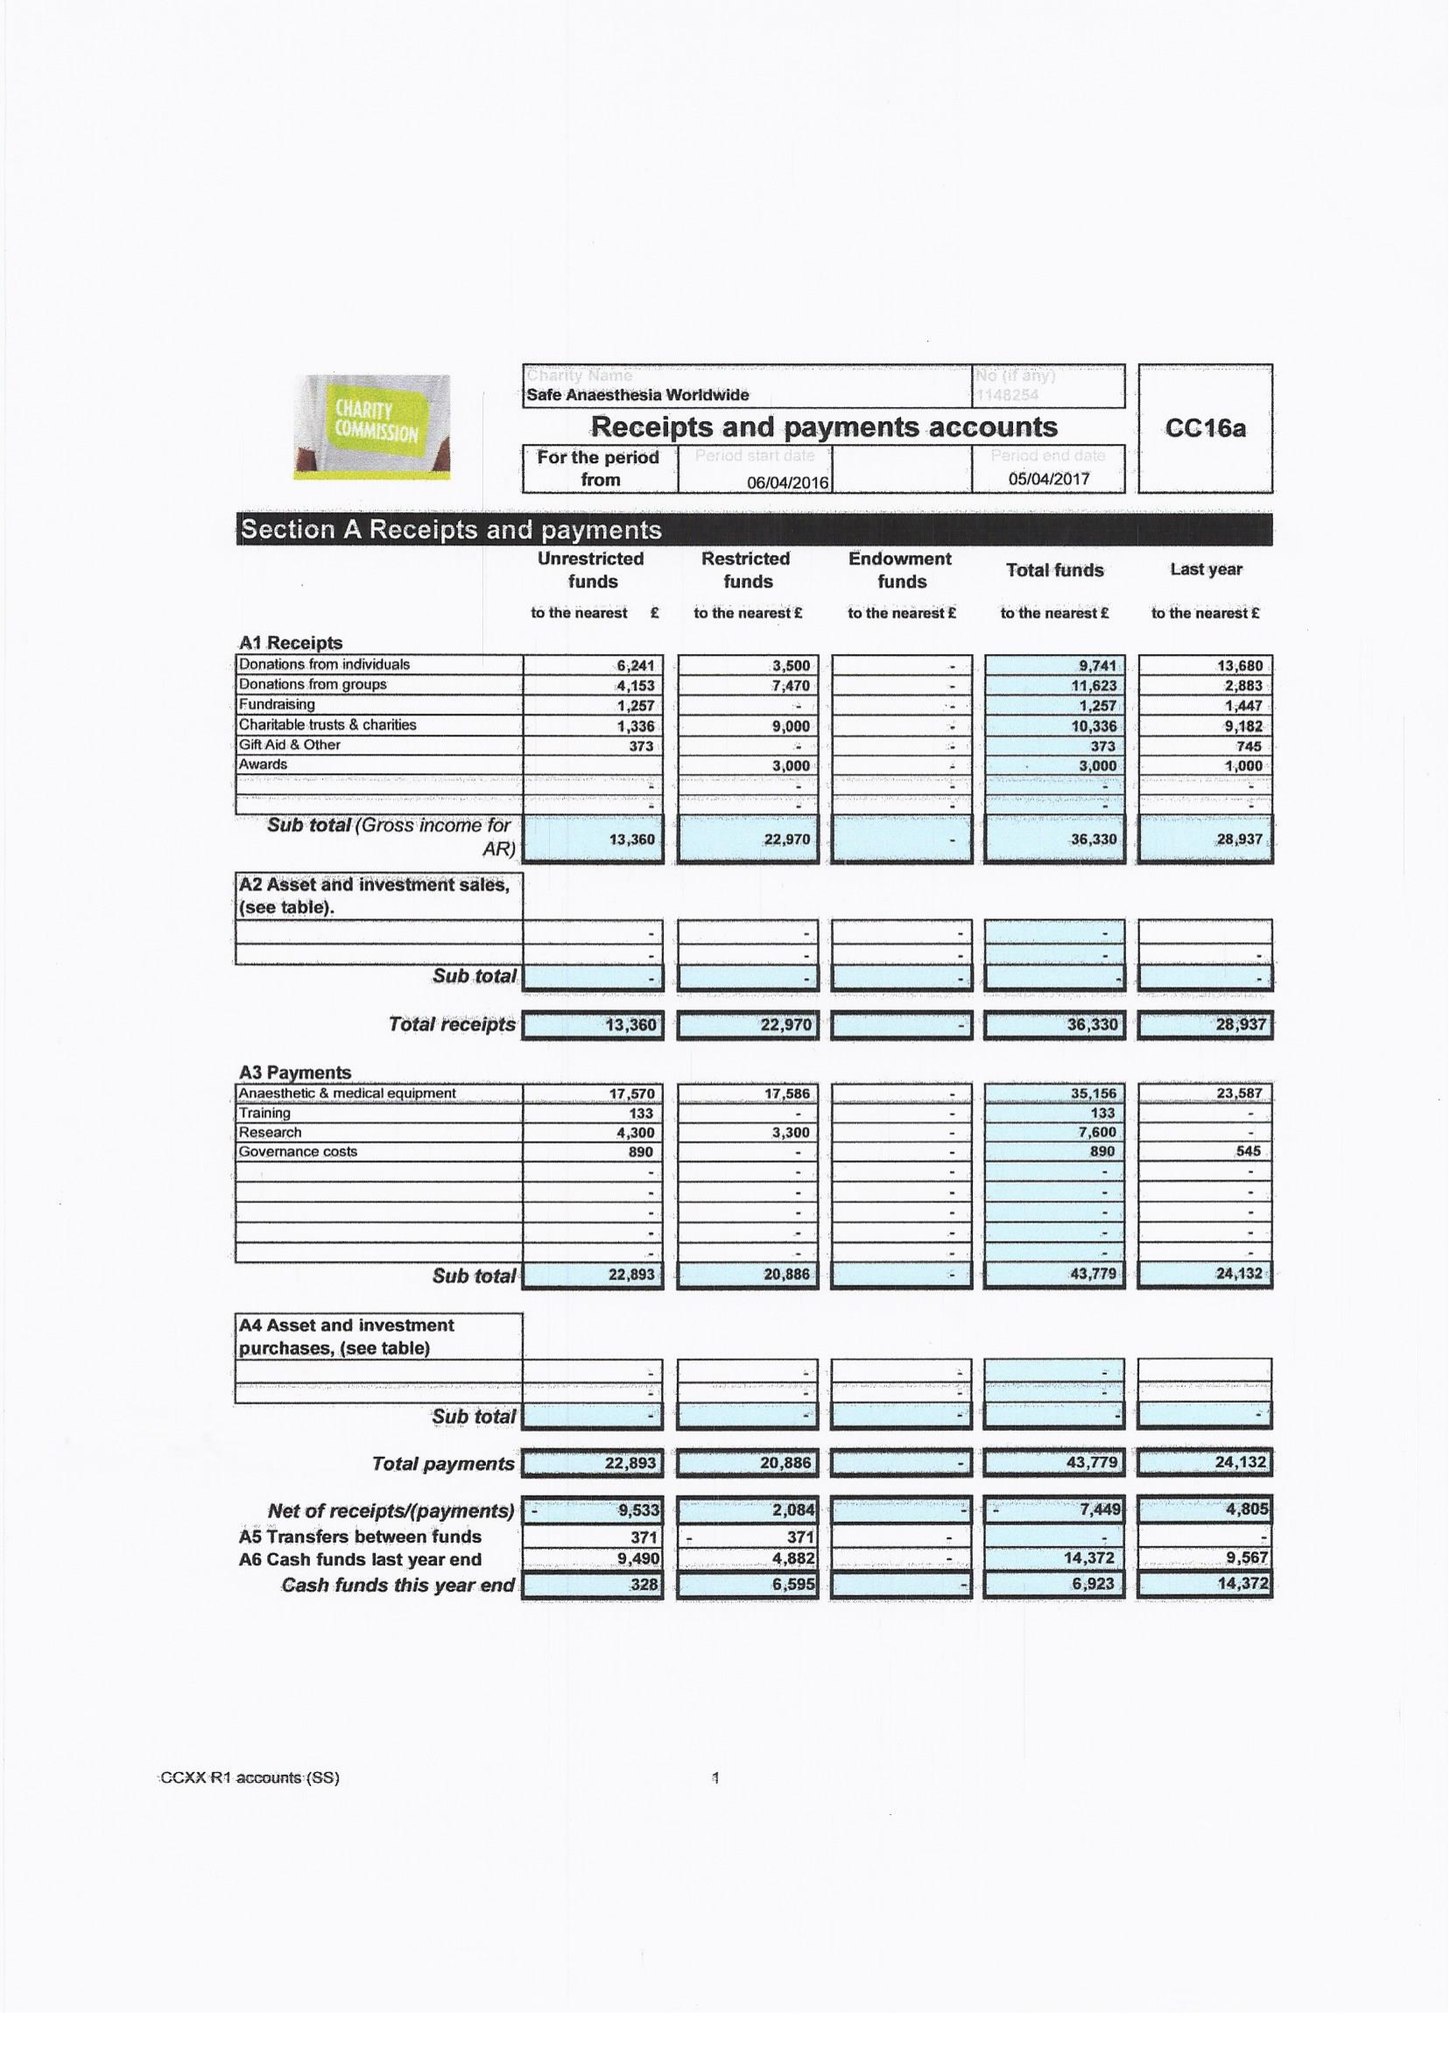What is the value for the address__post_town?
Answer the question using a single word or phrase. TONBRIDGE 